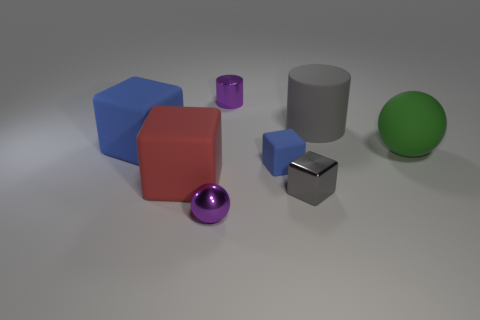What time of day does the lighting in this image suggest? The lighting in the image appears to be neutral, lacking any distinct shadows or warm tones that would suggest a time of day. It is likely an artificially lit environment meant to evenly showcase the objects without bias from natural light sources. 